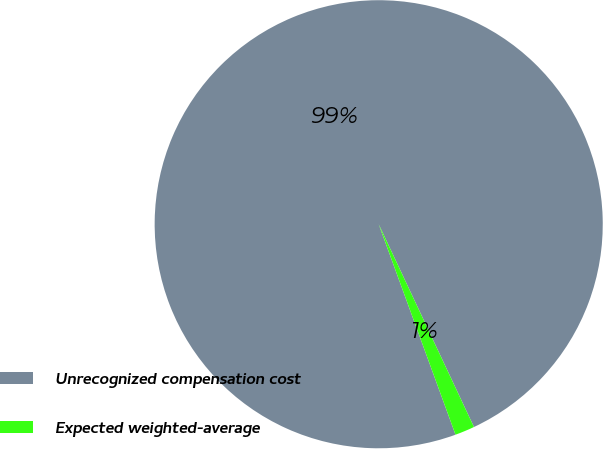Convert chart to OTSL. <chart><loc_0><loc_0><loc_500><loc_500><pie_chart><fcel>Unrecognized compensation cost<fcel>Expected weighted-average<nl><fcel>98.58%<fcel>1.42%<nl></chart> 